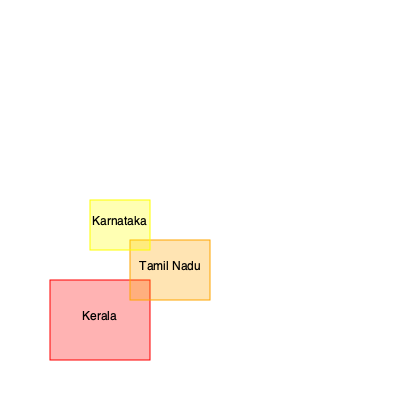Based on the highlighted regions in the map of India, which state is considered the birthplace of Kalaripayattu and shows the highest concentration of its practice? To answer this question, let's analyze the highlighted regions on the map:

1. The map shows three highlighted states in southern India.
2. Kerala (highlighted in red) is the southernmost and largest highlighted area.
3. Tamil Nadu (highlighted in orange) is to the east of Kerala.
4. Karnataka (highlighted in yellow) is to the north of Kerala and Tamil Nadu.

5. Historical context:
   - Kalaripayattu originated in Kerala, formerly known as Keralaputra.
   - It has been practiced in Kerala for over 3000 years.
   - The art form is deeply rooted in Kerala's culture and tradition.

6. Geographical spread:
   - While Kalaripayattu has influenced martial arts in neighboring states, its primary concentration remains in Kerala.
   - Tamil Nadu and Karnataka have some practice of Kalaripayattu, but to a lesser extent compared to Kerala.

7. Cultural significance:
   - Kerala continues to be the center for Kalaripayattu training and preservation.
   - The state hosts numerous Kalari schools (training centers) and regular performances.

Given this information, Kerala stands out as the birthplace and the state with the highest concentration of Kalaripayattu practice.
Answer: Kerala 